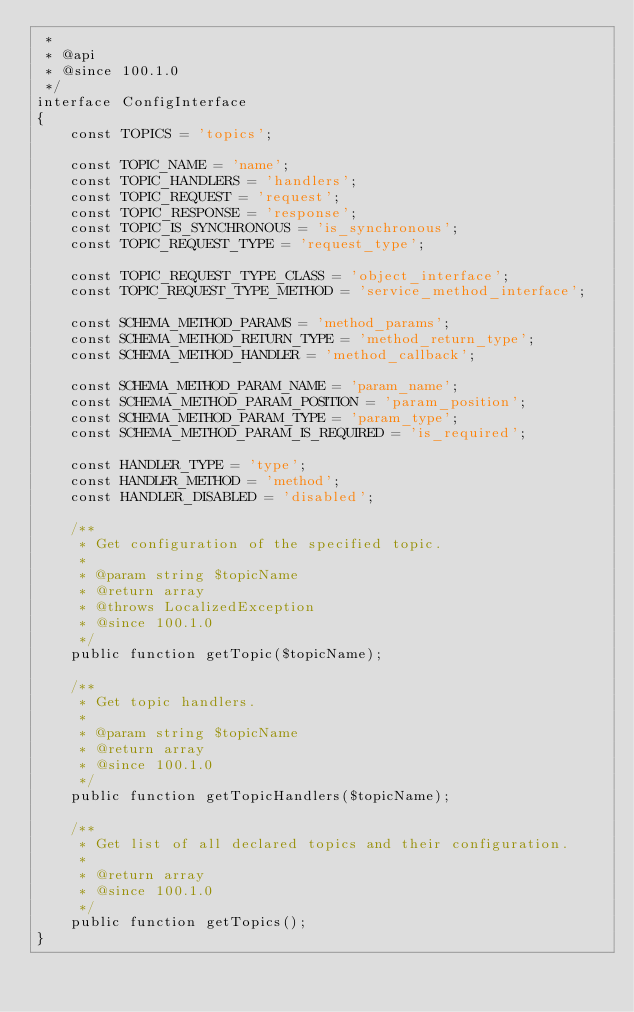Convert code to text. <code><loc_0><loc_0><loc_500><loc_500><_PHP_> *
 * @api
 * @since 100.1.0
 */
interface ConfigInterface
{
    const TOPICS = 'topics';

    const TOPIC_NAME = 'name';
    const TOPIC_HANDLERS = 'handlers';
    const TOPIC_REQUEST = 'request';
    const TOPIC_RESPONSE = 'response';
    const TOPIC_IS_SYNCHRONOUS = 'is_synchronous';
    const TOPIC_REQUEST_TYPE = 'request_type';

    const TOPIC_REQUEST_TYPE_CLASS = 'object_interface';
    const TOPIC_REQUEST_TYPE_METHOD = 'service_method_interface';

    const SCHEMA_METHOD_PARAMS = 'method_params';
    const SCHEMA_METHOD_RETURN_TYPE = 'method_return_type';
    const SCHEMA_METHOD_HANDLER = 'method_callback';

    const SCHEMA_METHOD_PARAM_NAME = 'param_name';
    const SCHEMA_METHOD_PARAM_POSITION = 'param_position';
    const SCHEMA_METHOD_PARAM_TYPE = 'param_type';
    const SCHEMA_METHOD_PARAM_IS_REQUIRED = 'is_required';

    const HANDLER_TYPE = 'type';
    const HANDLER_METHOD = 'method';
    const HANDLER_DISABLED = 'disabled';

    /**
     * Get configuration of the specified topic.
     *
     * @param string $topicName
     * @return array
     * @throws LocalizedException
     * @since 100.1.0
     */
    public function getTopic($topicName);

    /**
     * Get topic handlers.
     *
     * @param string $topicName
     * @return array
     * @since 100.1.0
     */
    public function getTopicHandlers($topicName);

    /**
     * Get list of all declared topics and their configuration.
     *
     * @return array
     * @since 100.1.0
     */
    public function getTopics();
}
</code> 